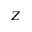<formula> <loc_0><loc_0><loc_500><loc_500>Z</formula> 